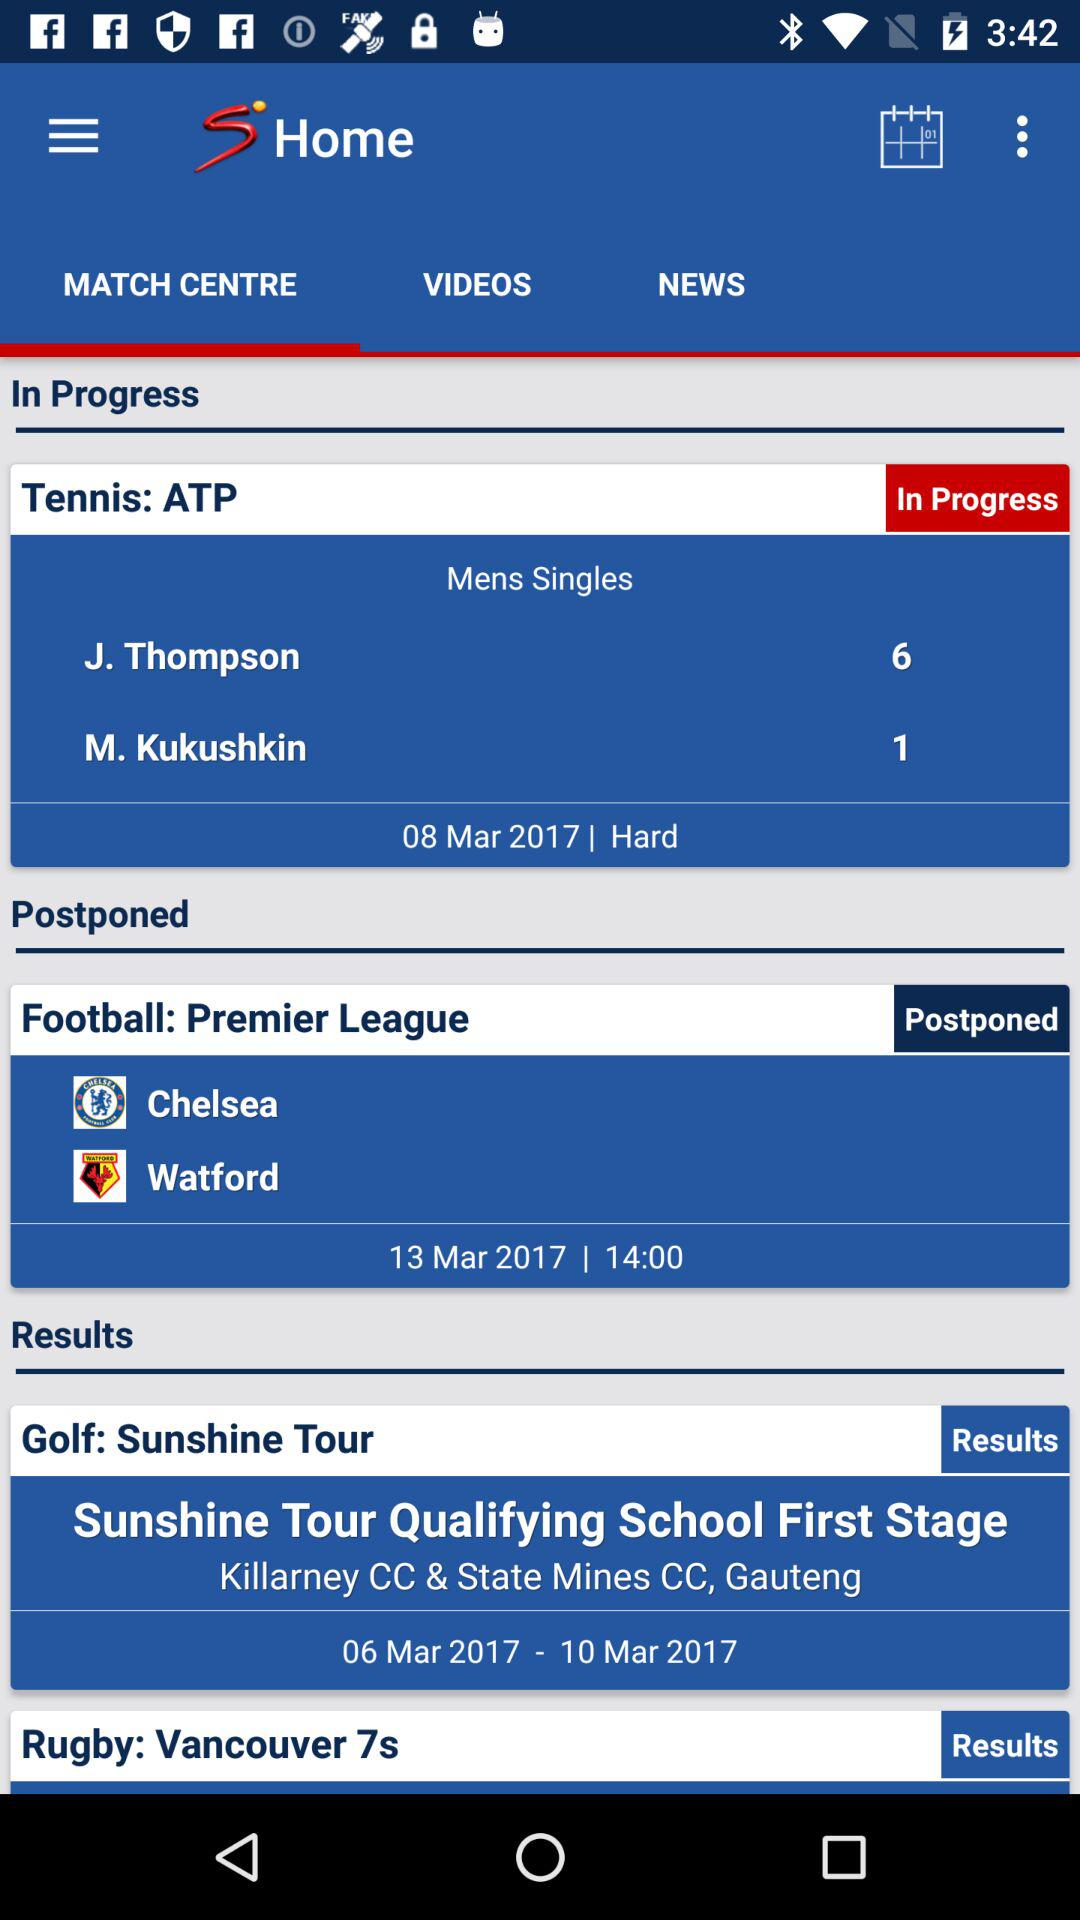How many matches are in progress?
Answer the question using a single word or phrase. 1 